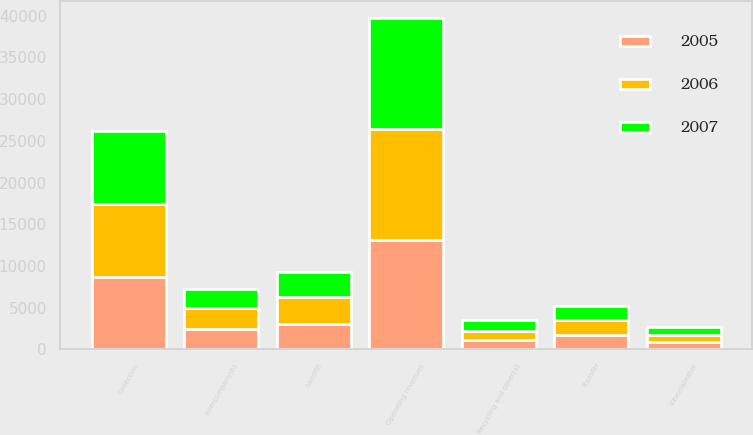<chart> <loc_0><loc_0><loc_500><loc_500><stacked_bar_chart><ecel><fcel>Collection<fcel>Landfill<fcel>Transfer<fcel>Wheelabrator<fcel>Recycling and other(a)<fcel>Intercompany(b)<fcel>Operating revenues<nl><fcel>2007<fcel>8714<fcel>3047<fcel>1654<fcel>868<fcel>1298<fcel>2271<fcel>13310<nl><fcel>2006<fcel>8837<fcel>3197<fcel>1802<fcel>902<fcel>1074<fcel>2449<fcel>13363<nl><fcel>2005<fcel>8633<fcel>3089<fcel>1756<fcel>879<fcel>1183<fcel>2466<fcel>13074<nl></chart> 